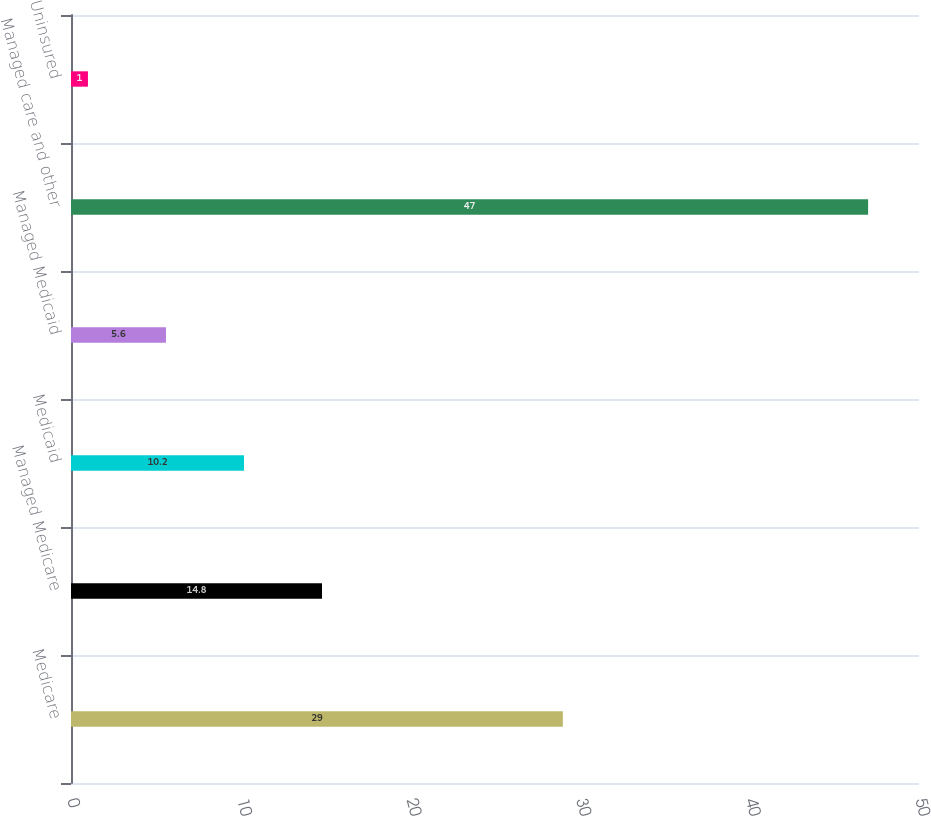Convert chart to OTSL. <chart><loc_0><loc_0><loc_500><loc_500><bar_chart><fcel>Medicare<fcel>Managed Medicare<fcel>Medicaid<fcel>Managed Medicaid<fcel>Managed care and other<fcel>Uninsured<nl><fcel>29<fcel>14.8<fcel>10.2<fcel>5.6<fcel>47<fcel>1<nl></chart> 